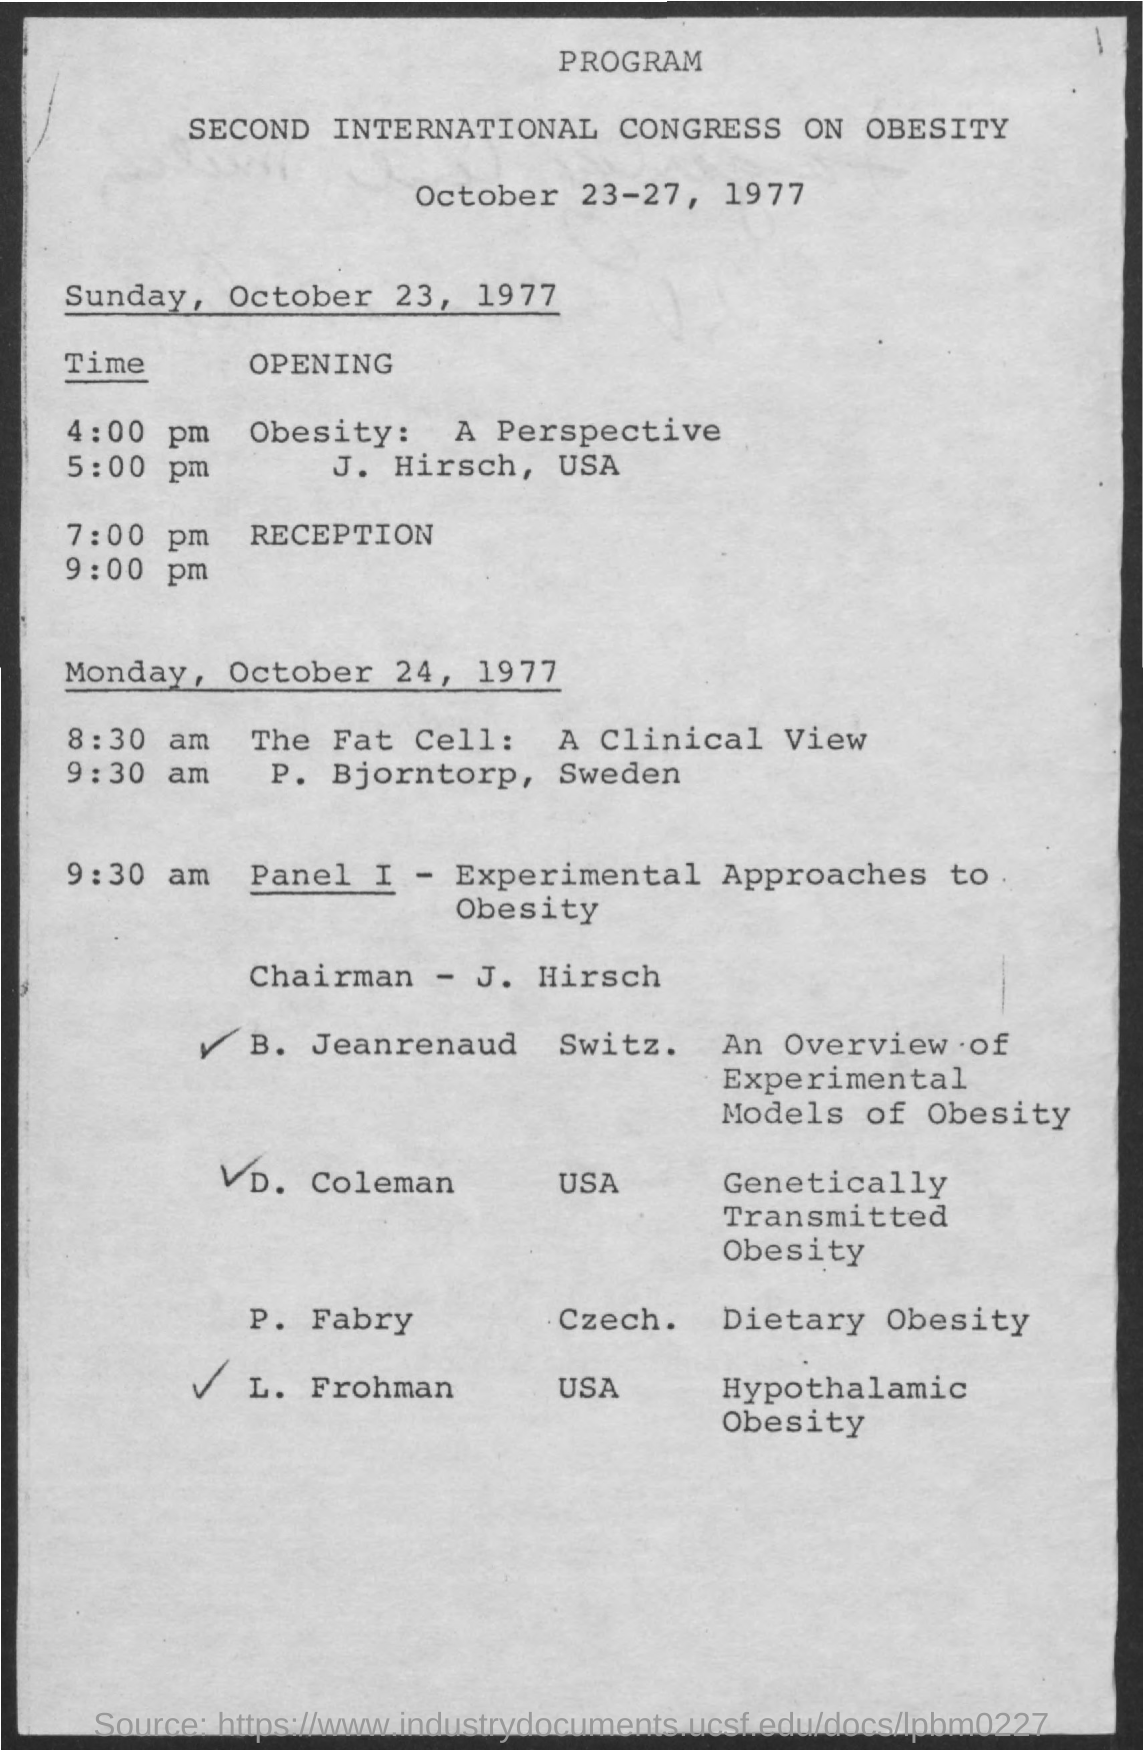List a handful of essential elements in this visual. The chairman's name is J Hirsch. October 23, 1977 was on a Sunday. On October 24, 1977, the date was Monday. The Second International Congress on Obesity is a program focused on the study and treatment of obesity. 